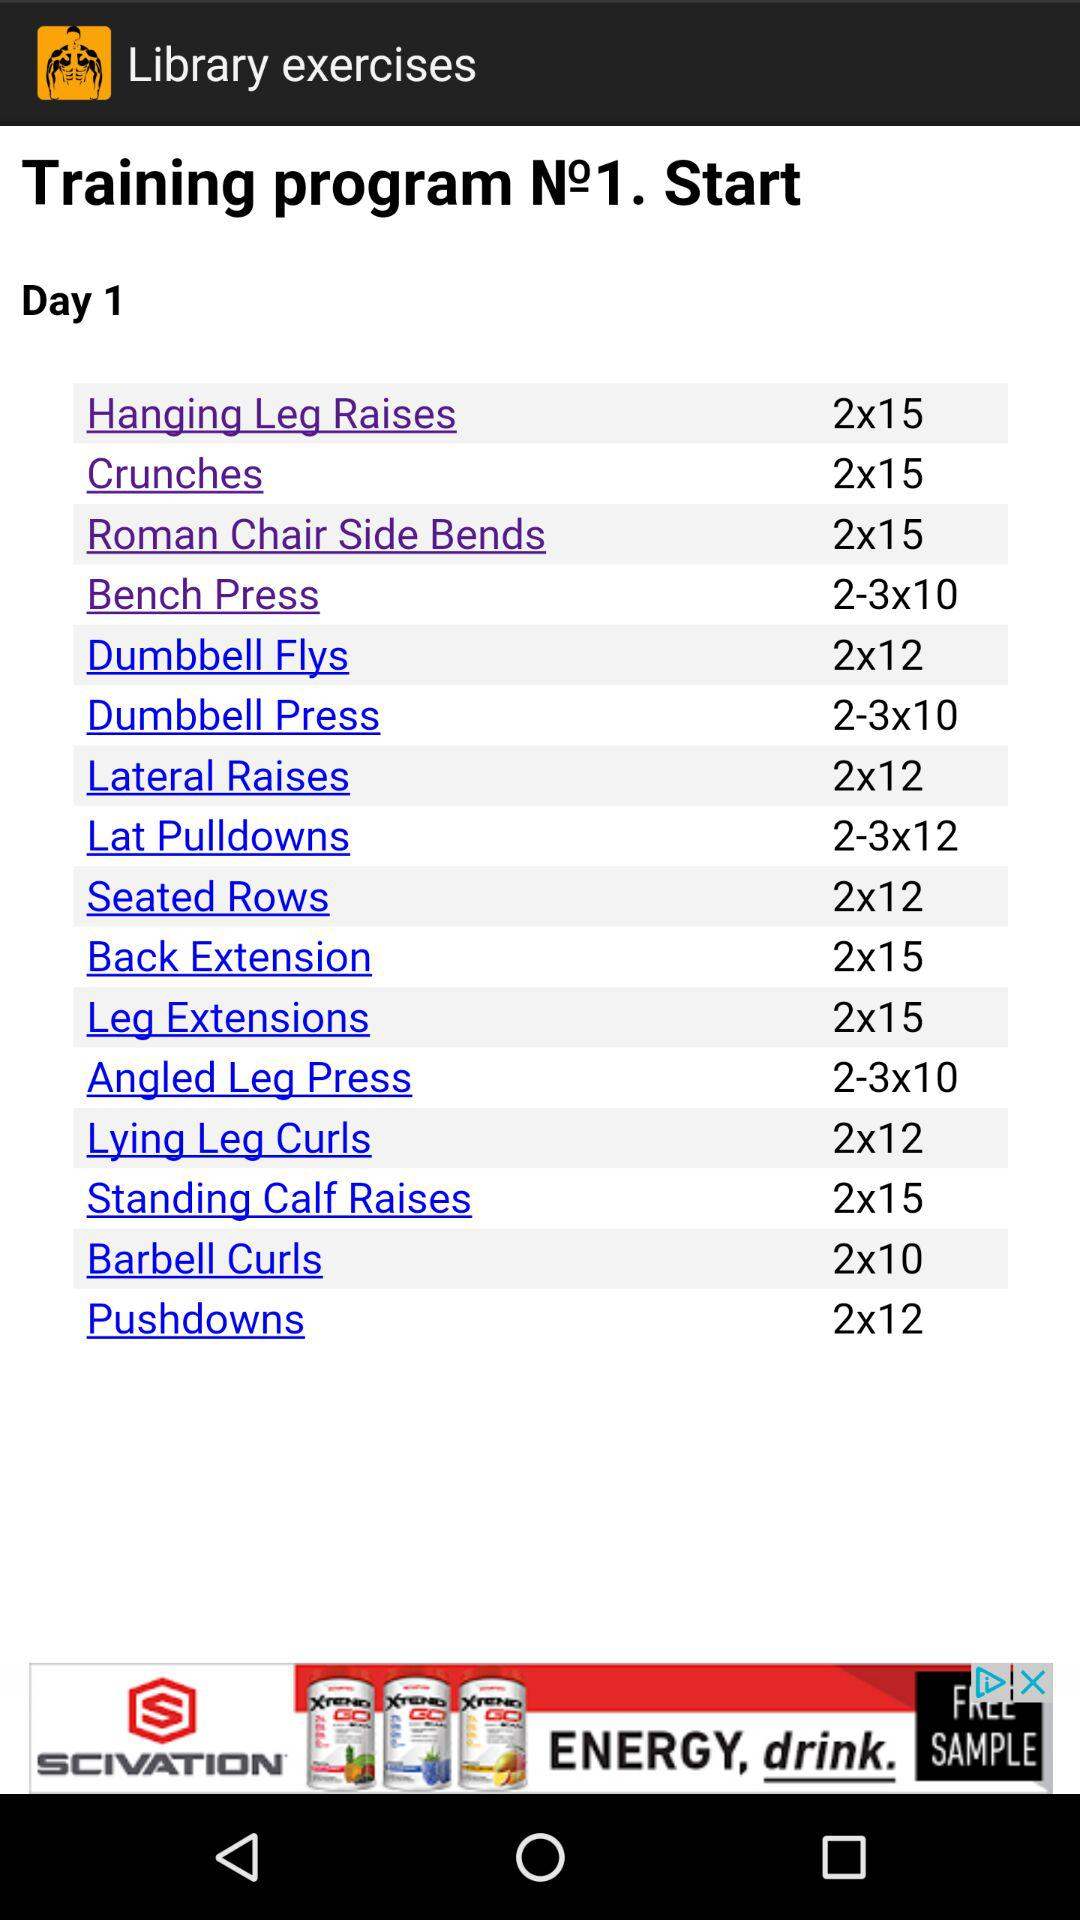What is the number of sets for the dumbbell press exercise? The number of sets for the dumbbell press exercise is 2 to 3. 